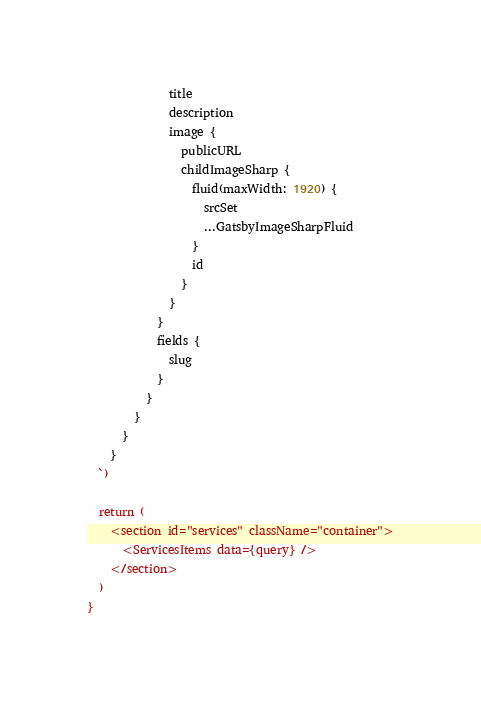<code> <loc_0><loc_0><loc_500><loc_500><_JavaScript_>              title
              description
              image {
                publicURL
                childImageSharp {
                  fluid(maxWidth: 1920) {
                    srcSet
                    ...GatsbyImageSharpFluid
                  }
                  id
                }
              }
            }
            fields {
              slug
            }
          }
        }
      }
    }
  `)

  return (
    <section id="services" className="container">
      <ServicesItems data={query} />
    </section>
  )
}
</code> 